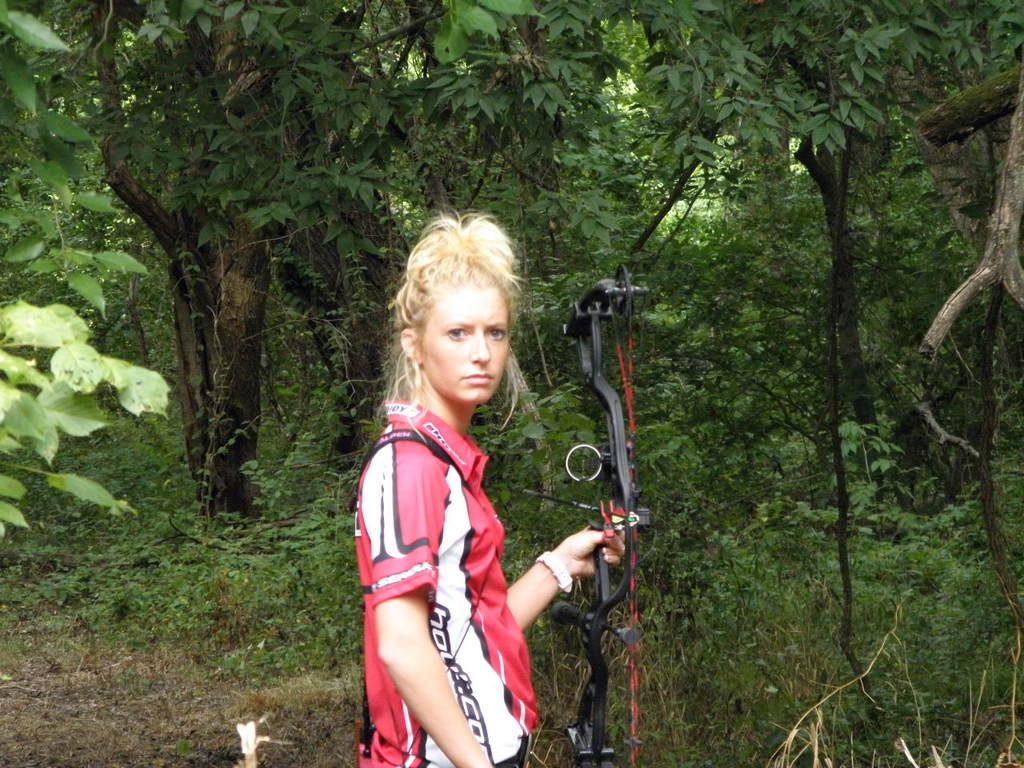Who is the main subject in the image? There is a woman in the image. What is the woman holding in her hand? The woman is holding a bow in her hand. What can be seen in the background of the image? There are trees in the background of the image. What type of laborer is working in the plantation shown in the image? There is no plantation or laborer present in the image; it features a woman holding a bow. What color is the woman's hair in the image? The provided facts do not mention the color of the woman's hair, so it cannot be determined from the image. 